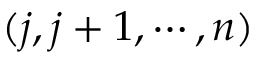Convert formula to latex. <formula><loc_0><loc_0><loc_500><loc_500>( j , j + 1 , \cdots , n )</formula> 